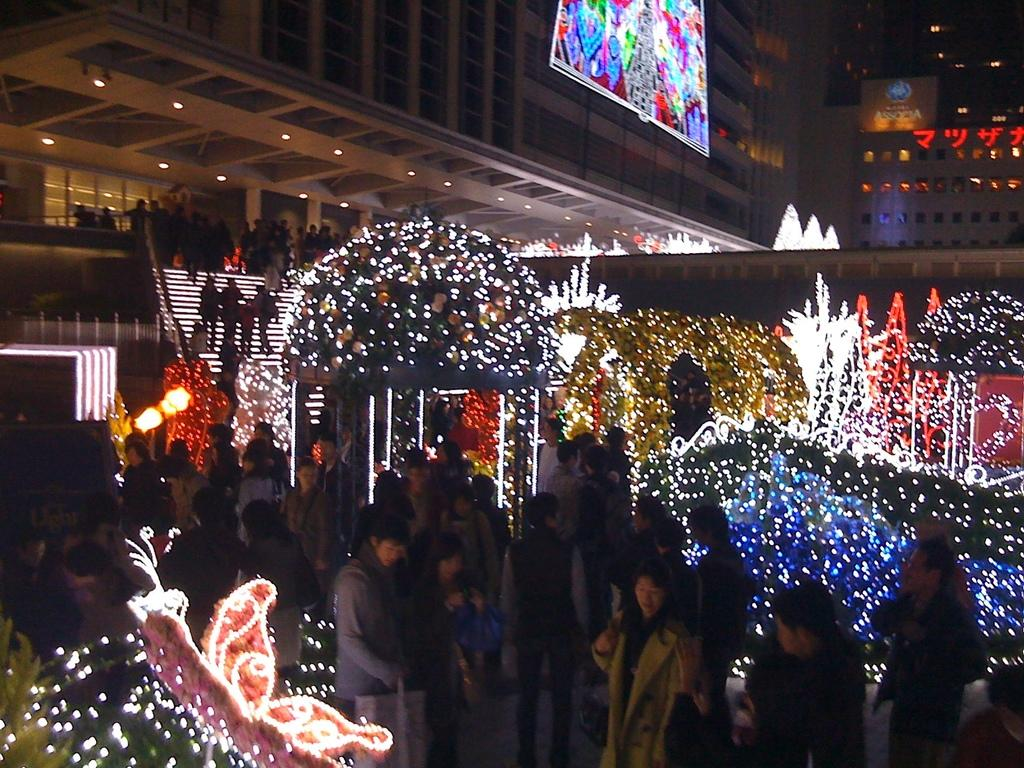What is happening with the group of people in the image? The group of people is standing on the floor. Can you describe the clothing of one of the individuals in the group? One woman in the group is wearing a coat. What can be seen in the background of the image? There is a staircase, a group of lights, buildings, and a screen visible in the background. What type of paste is being used by the goat in the image? There is no goat present in the image, so there is no paste being used. What type of club can be seen in the image? There is no club visible in the image. 